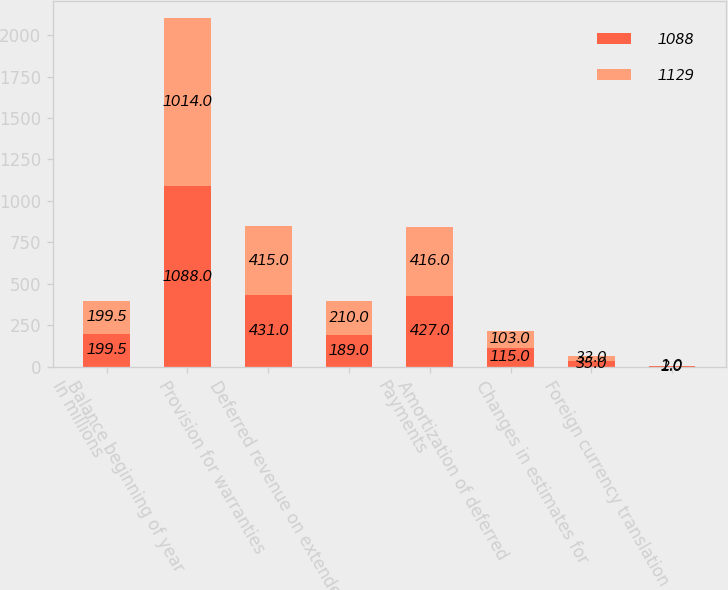<chart> <loc_0><loc_0><loc_500><loc_500><stacked_bar_chart><ecel><fcel>In millions<fcel>Balance beginning of year<fcel>Provision for warranties<fcel>Deferred revenue on extended<fcel>Payments<fcel>Amortization of deferred<fcel>Changes in estimates for<fcel>Foreign currency translation<nl><fcel>1088<fcel>199.5<fcel>1088<fcel>431<fcel>189<fcel>427<fcel>115<fcel>35<fcel>2<nl><fcel>1129<fcel>199.5<fcel>1014<fcel>415<fcel>210<fcel>416<fcel>103<fcel>33<fcel>1<nl></chart> 